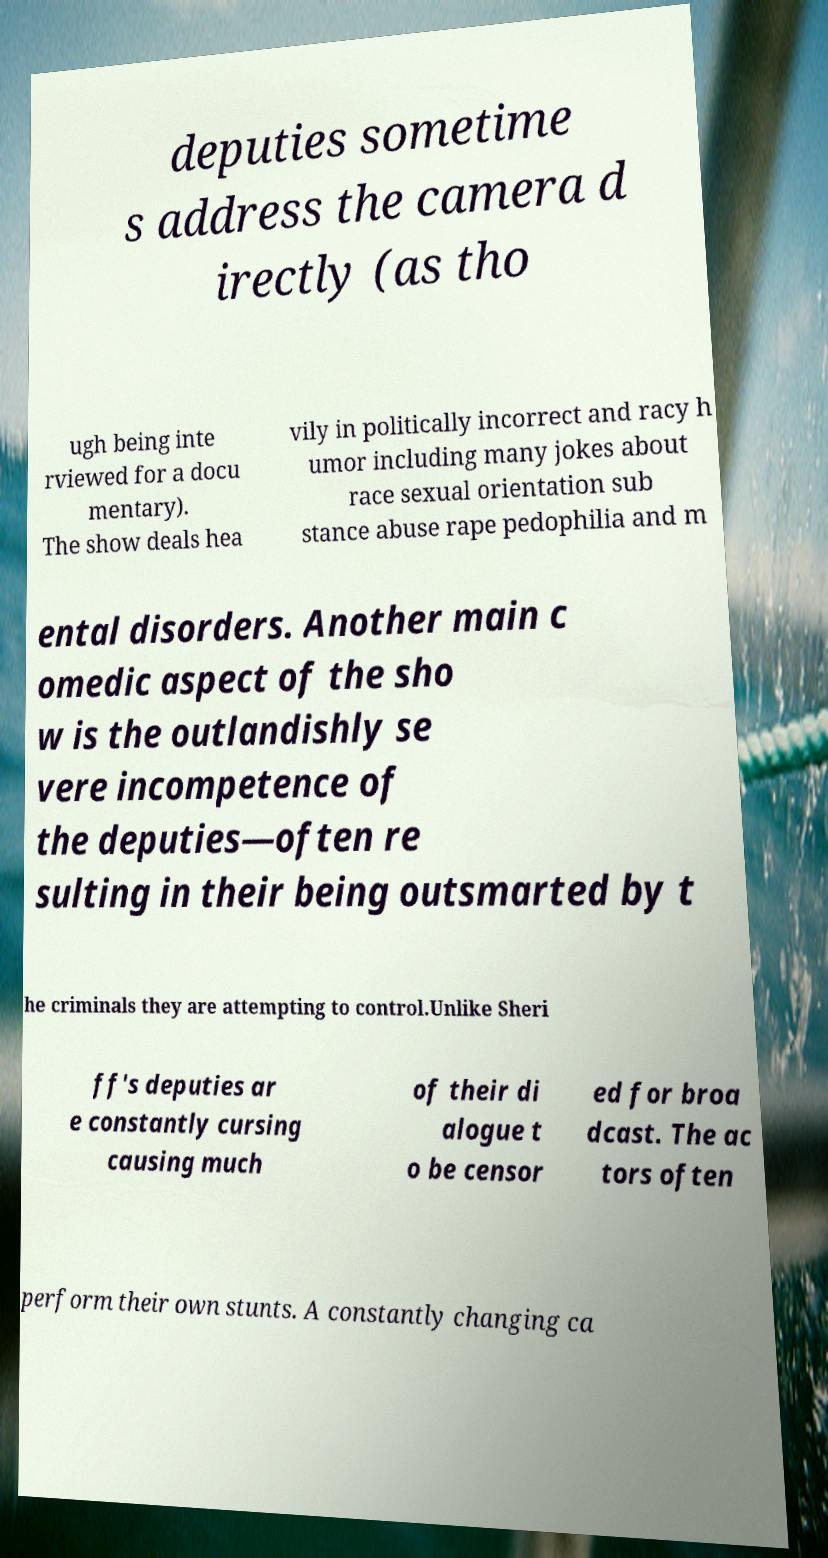Could you assist in decoding the text presented in this image and type it out clearly? deputies sometime s address the camera d irectly (as tho ugh being inte rviewed for a docu mentary). The show deals hea vily in politically incorrect and racy h umor including many jokes about race sexual orientation sub stance abuse rape pedophilia and m ental disorders. Another main c omedic aspect of the sho w is the outlandishly se vere incompetence of the deputies—often re sulting in their being outsmarted by t he criminals they are attempting to control.Unlike Sheri ff's deputies ar e constantly cursing causing much of their di alogue t o be censor ed for broa dcast. The ac tors often perform their own stunts. A constantly changing ca 